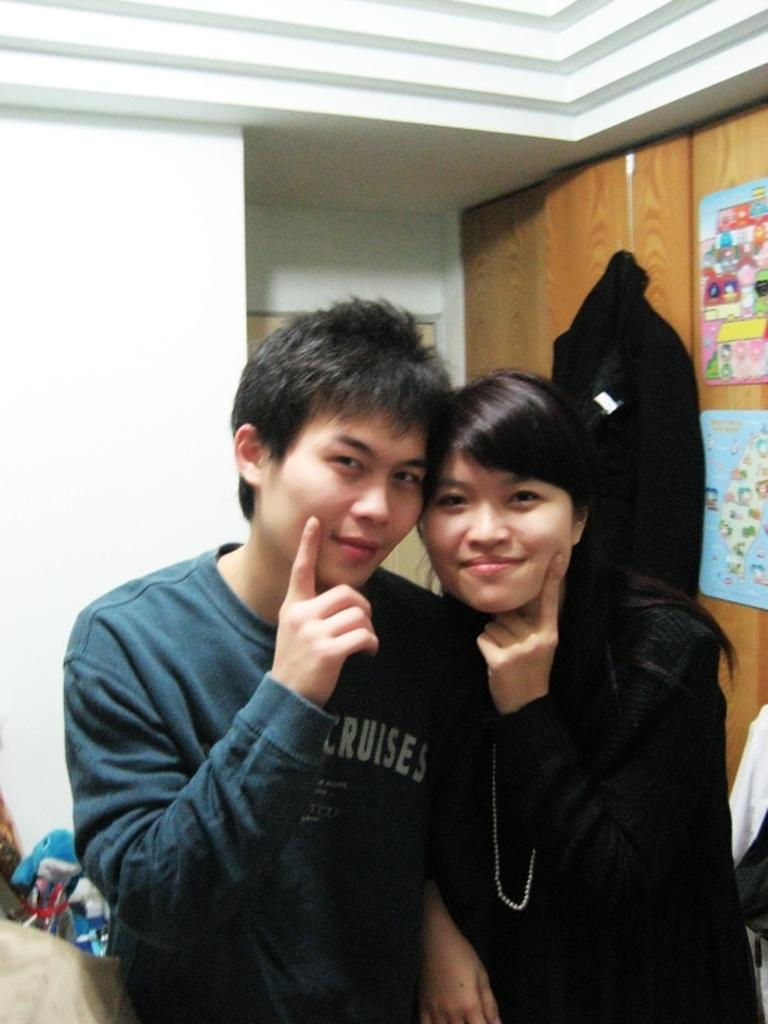How many people are in the image? There are two persons standing in the image. What is the facial expression of the persons? The persons are smiling. What can be seen on the cupboard in the image? There are papers stuck to a cupboard in the image. What type of items are visible in the image? There are toys and some objects in the image. What is the background of the image? There is a wall in the image. What type of soda is being consumed by the persons in the image? There is no soda present in the image; the persons are not consuming any beverages. 